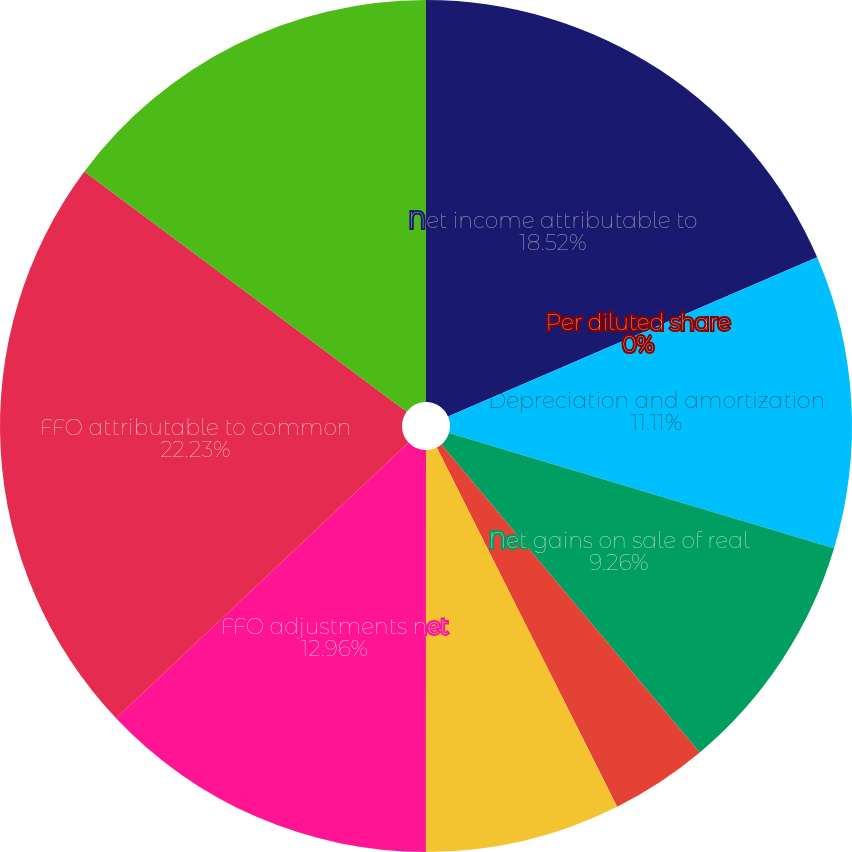Convert chart to OTSL. <chart><loc_0><loc_0><loc_500><loc_500><pie_chart><fcel>Net income attributable to<fcel>Per diluted share<fcel>Depreciation and amortization<fcel>Net gains on sale of real<fcel>Real estate impairment losses<fcel>Noncontrolling interests'<fcel>FFO adjustments net<fcel>FFO attributable to common<fcel>Weighted average common shares<nl><fcel>18.52%<fcel>0.0%<fcel>11.11%<fcel>9.26%<fcel>3.7%<fcel>7.41%<fcel>12.96%<fcel>22.22%<fcel>14.81%<nl></chart> 